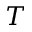Convert formula to latex. <formula><loc_0><loc_0><loc_500><loc_500>T</formula> 